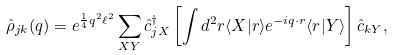<formula> <loc_0><loc_0><loc_500><loc_500>\hat { \rho } _ { j k } ( { q } ) = e ^ { \frac { 1 } { 4 } q ^ { 2 } \ell ^ { 2 } } \sum _ { X Y } \hat { c } ^ { \dagger } _ { j X } \left [ \int d ^ { 2 } r \langle X | { r } \rangle e ^ { - i { q } \cdot { r } } \langle { r } | Y \rangle \right ] \hat { c } _ { k Y } ,</formula> 